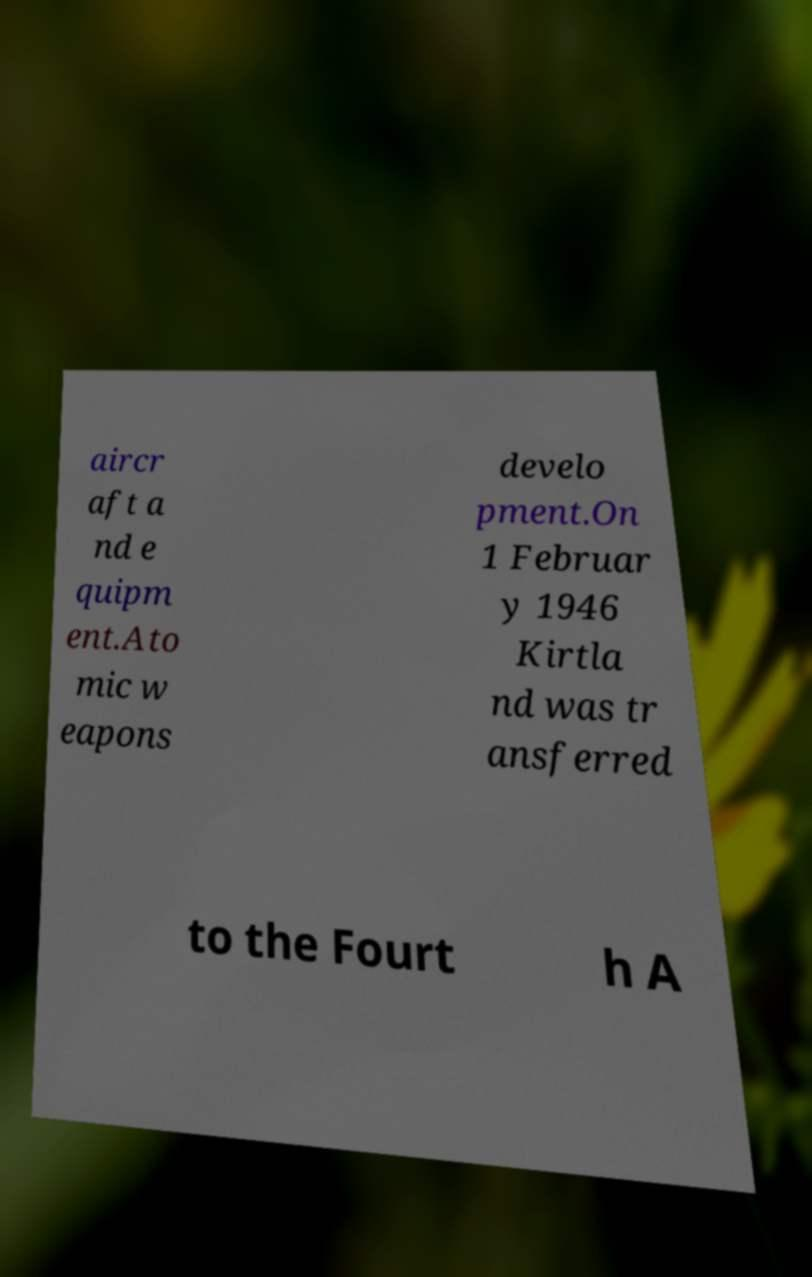What messages or text are displayed in this image? I need them in a readable, typed format. aircr aft a nd e quipm ent.Ato mic w eapons develo pment.On 1 Februar y 1946 Kirtla nd was tr ansferred to the Fourt h A 